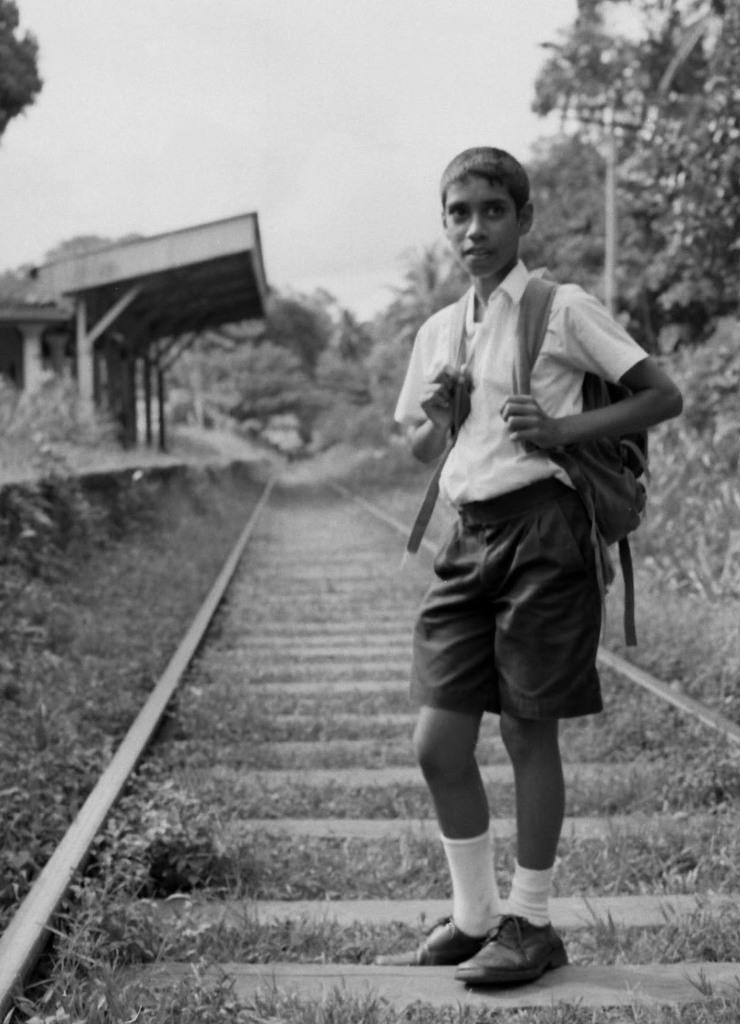Who is present in the image? There is a boy in the image. What is the boy doing in the image? The boy is standing in the image. What is the boy wearing? The boy is wearing clothes, socks, and shoes in the image. What is the boy carrying in the image? The boy is carrying a bag on his back in the image. What can be seen in the background of the image? There are train tracks, grass, trees, a pole, and the sky visible in the image. What is the location of the image? The location is a station. How many girls are present in the image? There are no girls present in the image; only a boy is visible. What type of needle is the boy using to write his name on the pole? There is no needle or writing present in the image. 